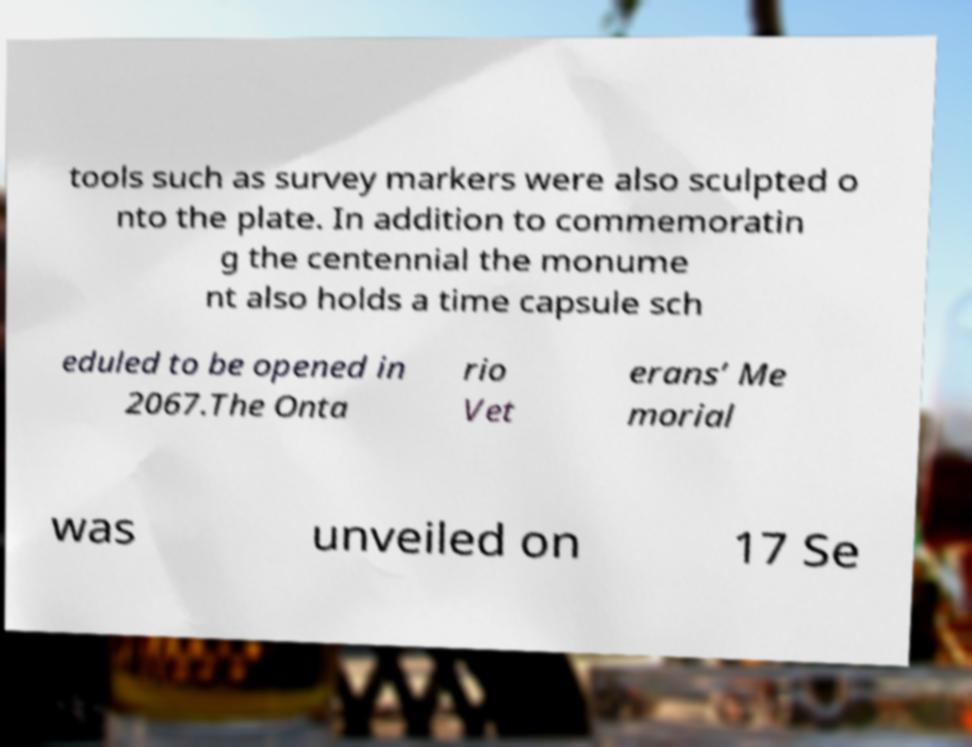What messages or text are displayed in this image? I need them in a readable, typed format. tools such as survey markers were also sculpted o nto the plate. In addition to commemoratin g the centennial the monume nt also holds a time capsule sch eduled to be opened in 2067.The Onta rio Vet erans’ Me morial was unveiled on 17 Se 